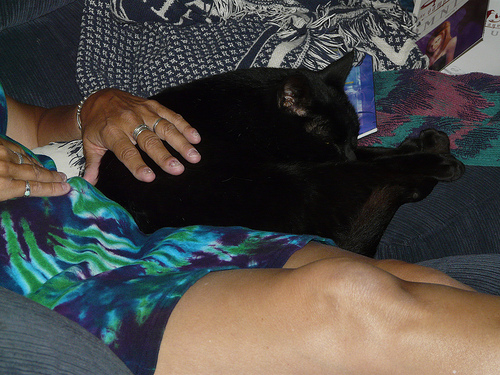<image>
Is the cat behind the woman? No. The cat is not behind the woman. From this viewpoint, the cat appears to be positioned elsewhere in the scene. 